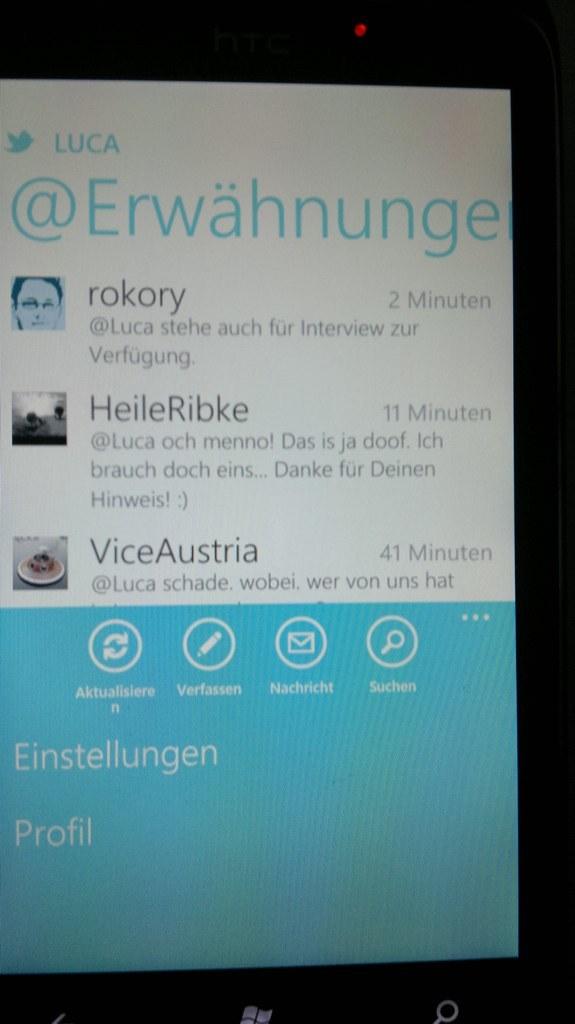What is the word next to the twitter bird on the top?
Provide a succinct answer. Luca. 